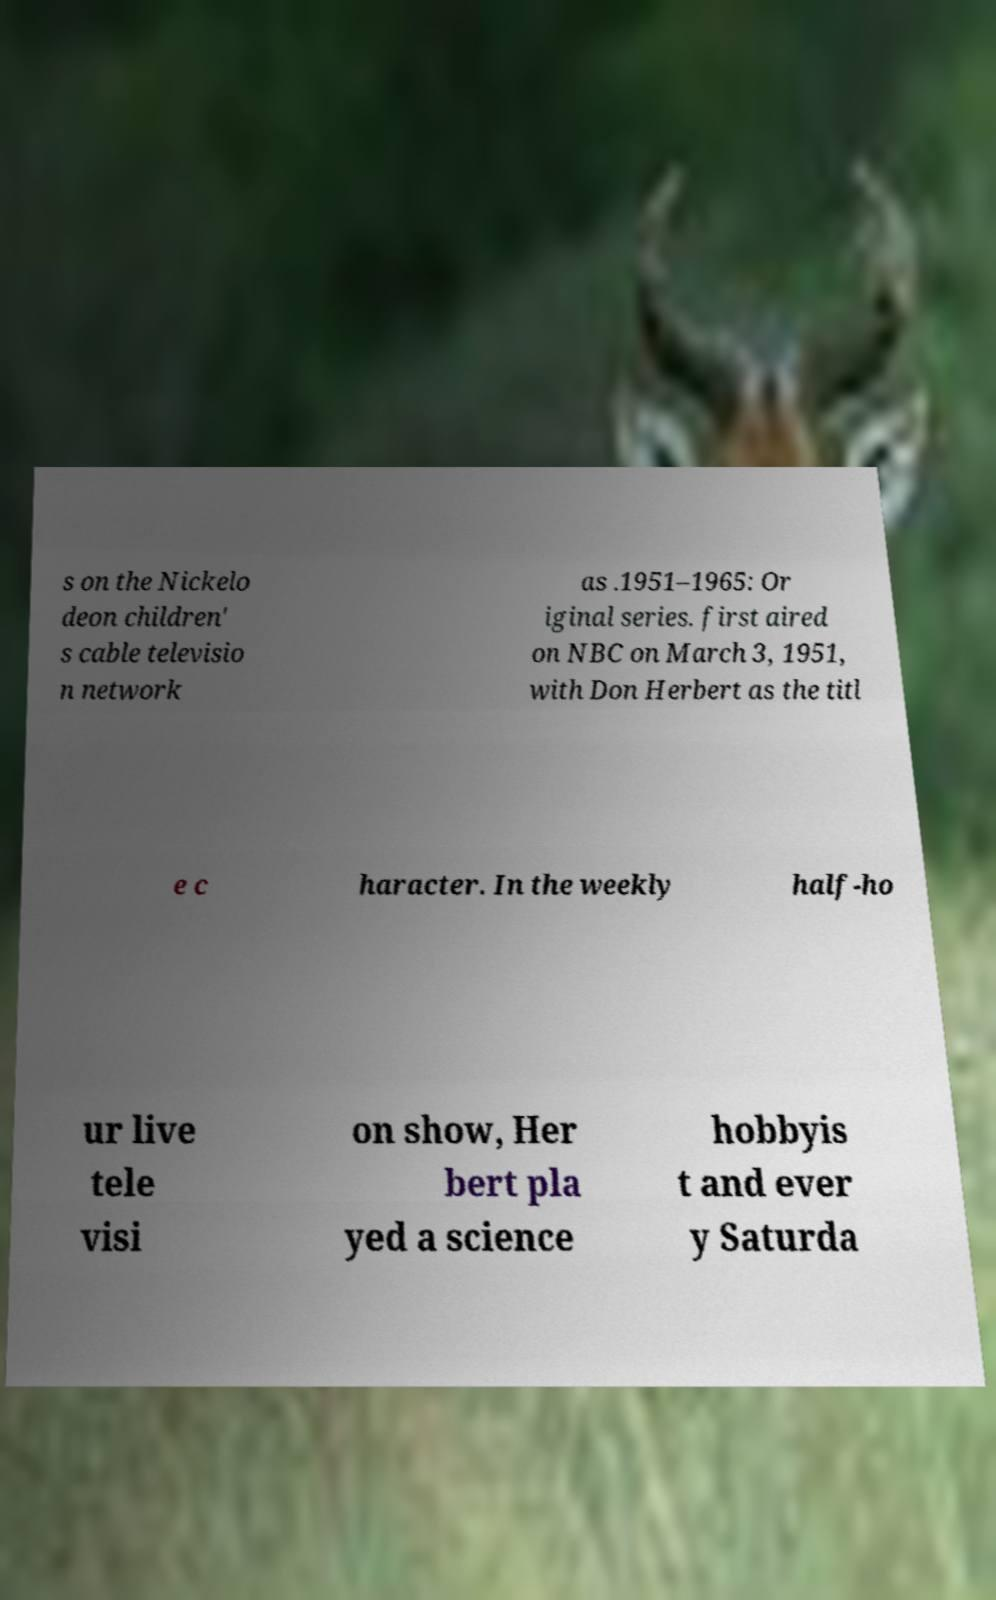Could you extract and type out the text from this image? s on the Nickelo deon children' s cable televisio n network as .1951–1965: Or iginal series. first aired on NBC on March 3, 1951, with Don Herbert as the titl e c haracter. In the weekly half-ho ur live tele visi on show, Her bert pla yed a science hobbyis t and ever y Saturda 